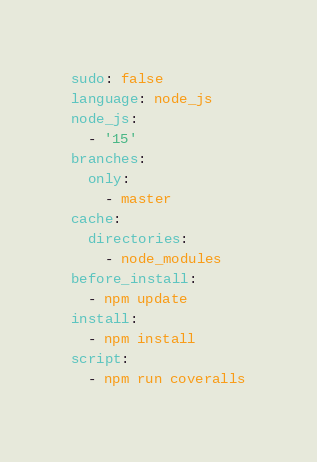<code> <loc_0><loc_0><loc_500><loc_500><_YAML_>sudo: false
language: node_js
node_js:
  - '15'
branches:
  only:
    - master
cache:
  directories:
    - node_modules
before_install:
  - npm update
install:
  - npm install
script:
  - npm run coveralls
</code> 